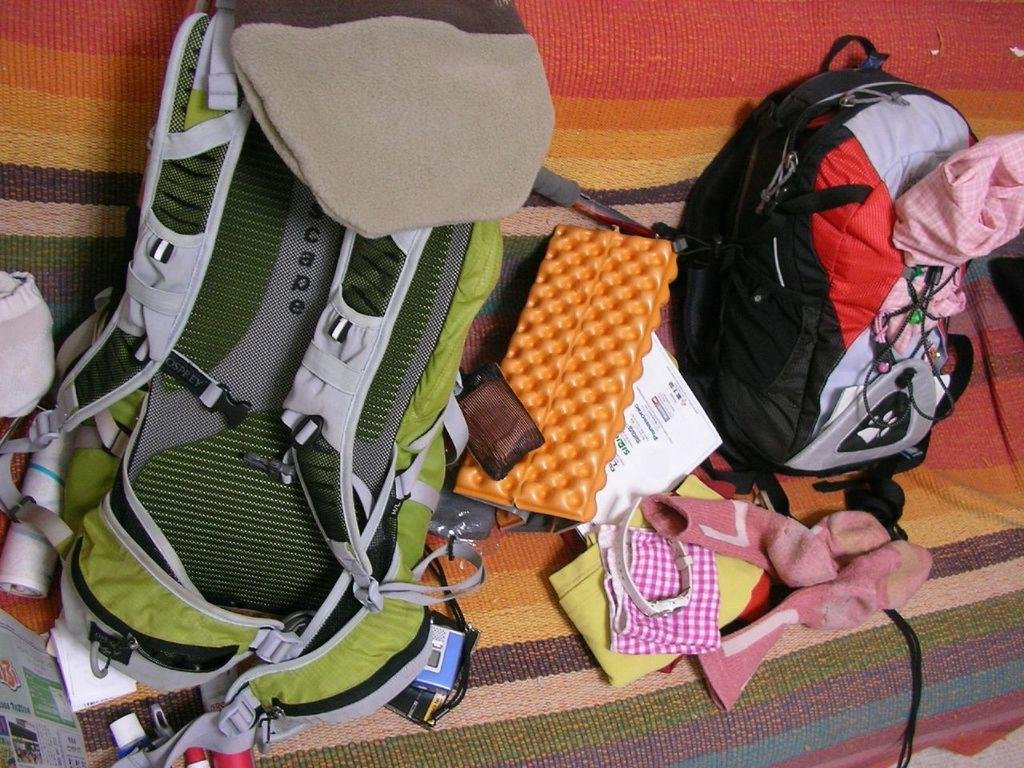What items are placed on the mat in the image? There are two backpacks, a set of socks, and a watch on the mat. How many backpacks are on the mat? There are two backpacks on the mat. What type of clothing item is on the mat? There is a set of socks on the mat. What accessory is on the mat? There is a watch on the mat. What trail can be seen in the image? There is no trail present in the image; it features items placed on a mat. How many brothers are visible in the image? There are no people, let alone brothers, visible in the image. 